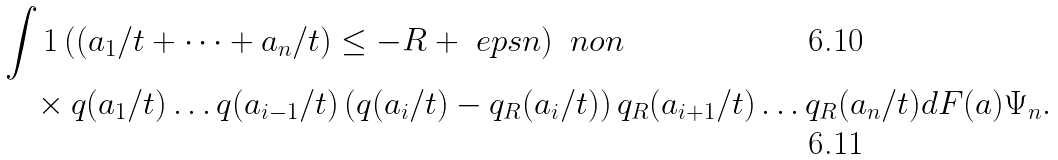<formula> <loc_0><loc_0><loc_500><loc_500>& \int 1 \left ( ( a _ { 1 } / t + \cdots + a _ { n } / t ) \leq - R + \ e p s n \right ) \ n o n \\ & \quad \times q ( a _ { 1 } / t ) \dots q ( a _ { i - 1 } / t ) \left ( q ( a _ { i } / t ) - q _ { R } ( a _ { i } / t ) \right ) q _ { R } ( a _ { i + 1 } / t ) \dots q _ { R } ( a _ { n } / t ) d F ( a ) \Psi _ { n } .</formula> 